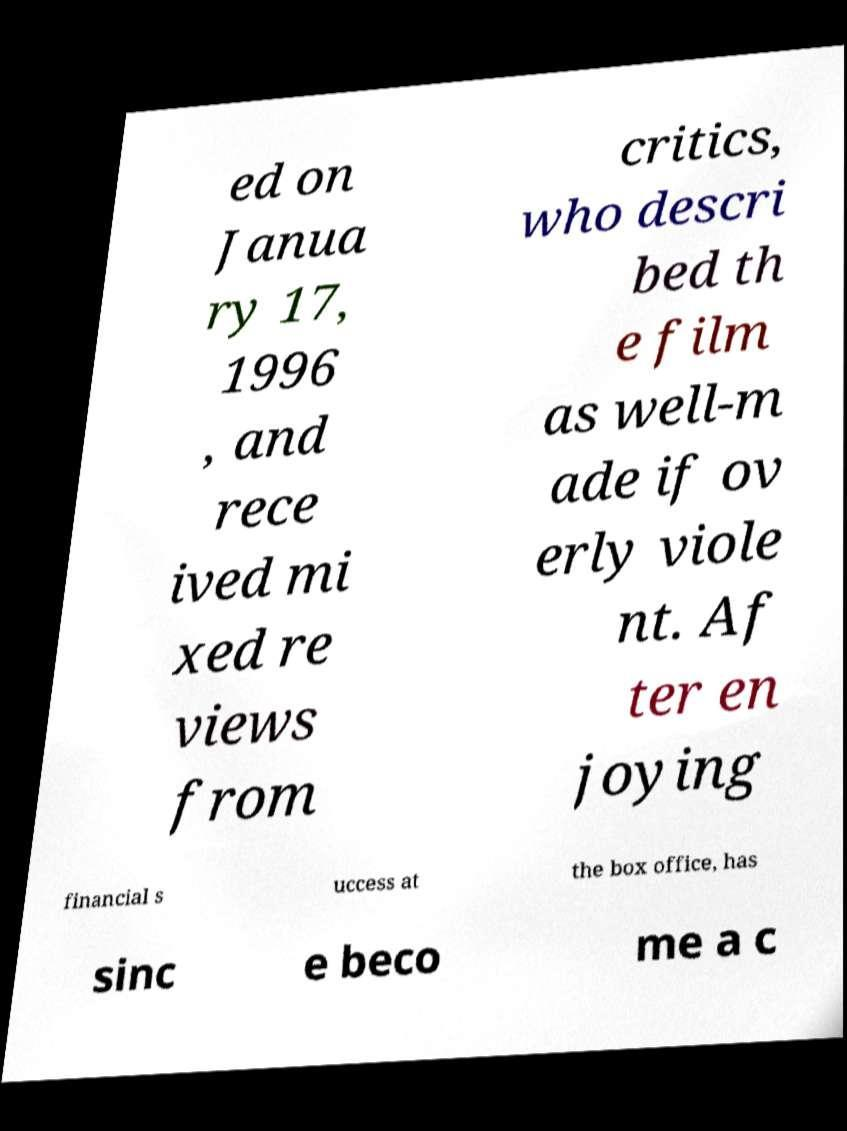Please identify and transcribe the text found in this image. ed on Janua ry 17, 1996 , and rece ived mi xed re views from critics, who descri bed th e film as well-m ade if ov erly viole nt. Af ter en joying financial s uccess at the box office, has sinc e beco me a c 